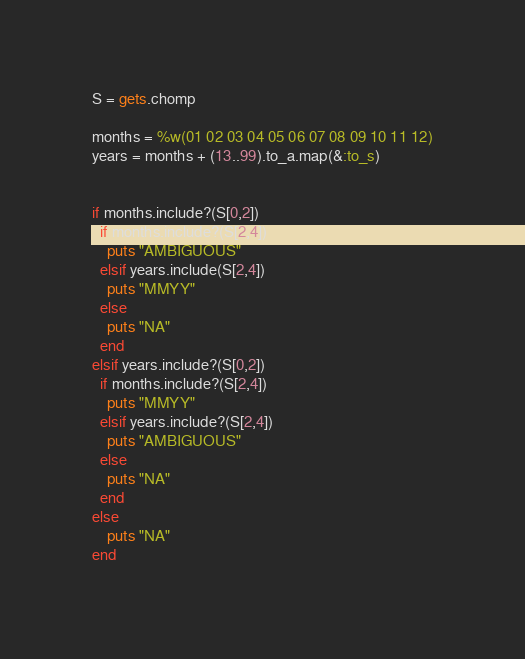<code> <loc_0><loc_0><loc_500><loc_500><_Ruby_>S = gets.chomp

months = %w(01 02 03 04 05 06 07 08 09 10 11 12)
years = months + (13..99).to_a.map(&:to_s)


if months.include?(S[0,2])
  if months.include?(S[2,4])
    puts "AMBIGUOUS"
  elsif years.include(S[2,4])
    puts "MMYY"
  else
    puts "NA"
  end
elsif years.include?(S[0,2])
  if months.include?(S[2,4])
    puts "MMYY"
  elsif years.include?(S[2,4])
    puts "AMBIGUOUS"
  else
    puts "NA"
  end
else
	puts "NA"
end
</code> 